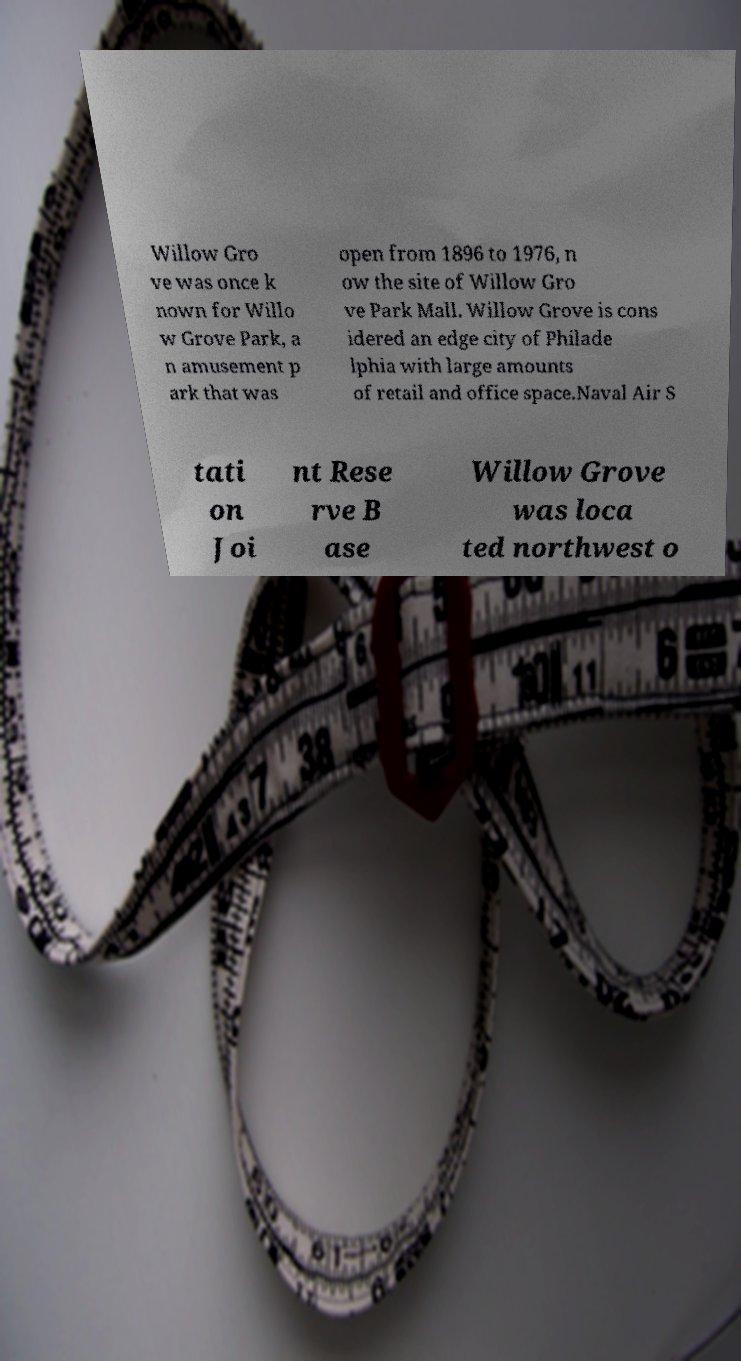For documentation purposes, I need the text within this image transcribed. Could you provide that? Willow Gro ve was once k nown for Willo w Grove Park, a n amusement p ark that was open from 1896 to 1976, n ow the site of Willow Gro ve Park Mall. Willow Grove is cons idered an edge city of Philade lphia with large amounts of retail and office space.Naval Air S tati on Joi nt Rese rve B ase Willow Grove was loca ted northwest o 